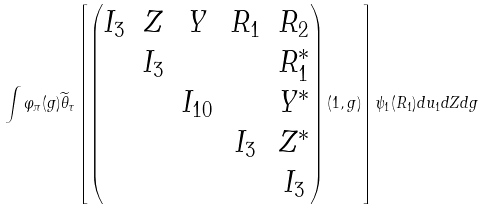<formula> <loc_0><loc_0><loc_500><loc_500>\int \varphi _ { \pi } ( g ) \widetilde { \theta } _ { \tau } \left [ \begin{pmatrix} I _ { 3 } & Z & Y & R _ { 1 } & R _ { 2 } \\ & I _ { 3 } & & & R _ { 1 } ^ { * } \\ & & I _ { 1 0 } & & Y ^ { * } \\ & & & I _ { 3 } & Z ^ { * } \\ & & & & I _ { 3 } \end{pmatrix} ( 1 , g ) \right ] \psi _ { 1 } ( R _ { 1 } ) d u _ { 1 } d Z d g</formula> 